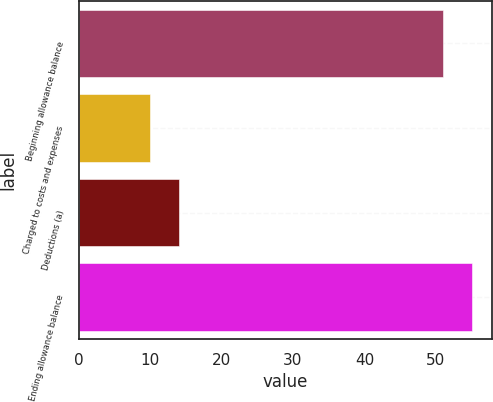<chart> <loc_0><loc_0><loc_500><loc_500><bar_chart><fcel>Beginning allowance balance<fcel>Charged to costs and expenses<fcel>Deductions (a)<fcel>Ending allowance balance<nl><fcel>51<fcel>10<fcel>14.1<fcel>55.1<nl></chart> 